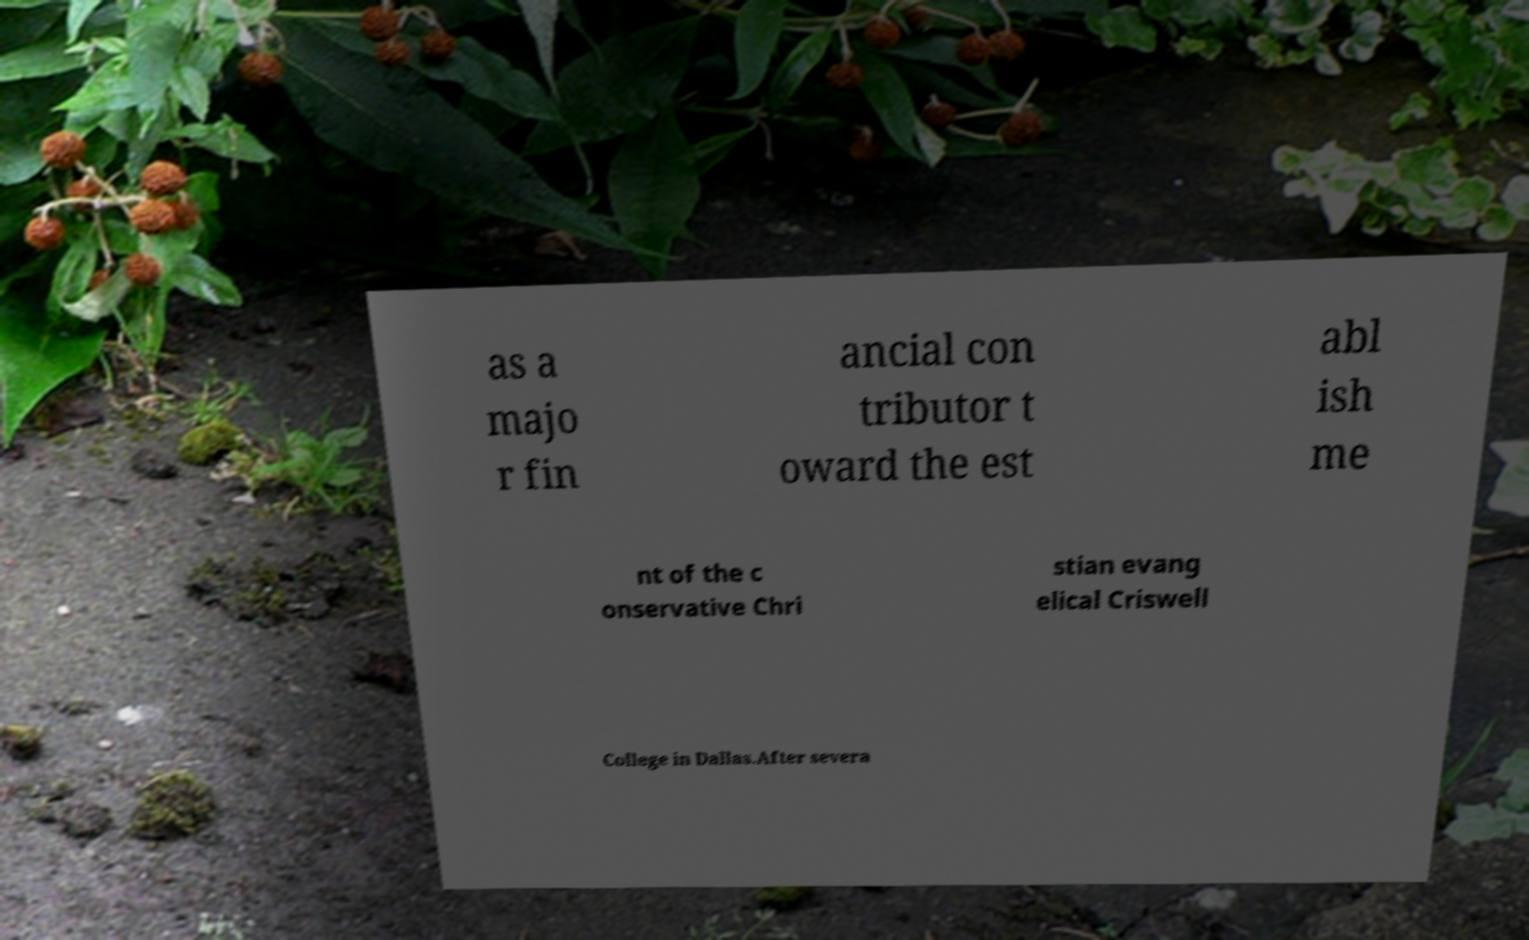There's text embedded in this image that I need extracted. Can you transcribe it verbatim? as a majo r fin ancial con tributor t oward the est abl ish me nt of the c onservative Chri stian evang elical Criswell College in Dallas.After severa 